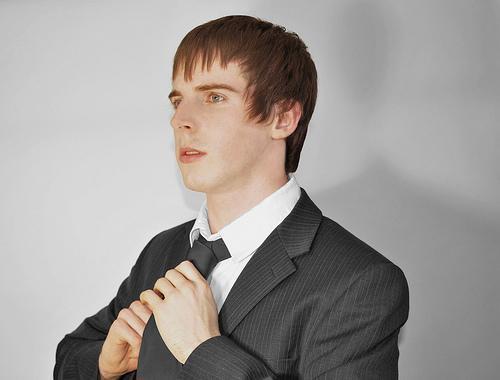How many hands does the man have?
Give a very brief answer. 2. 